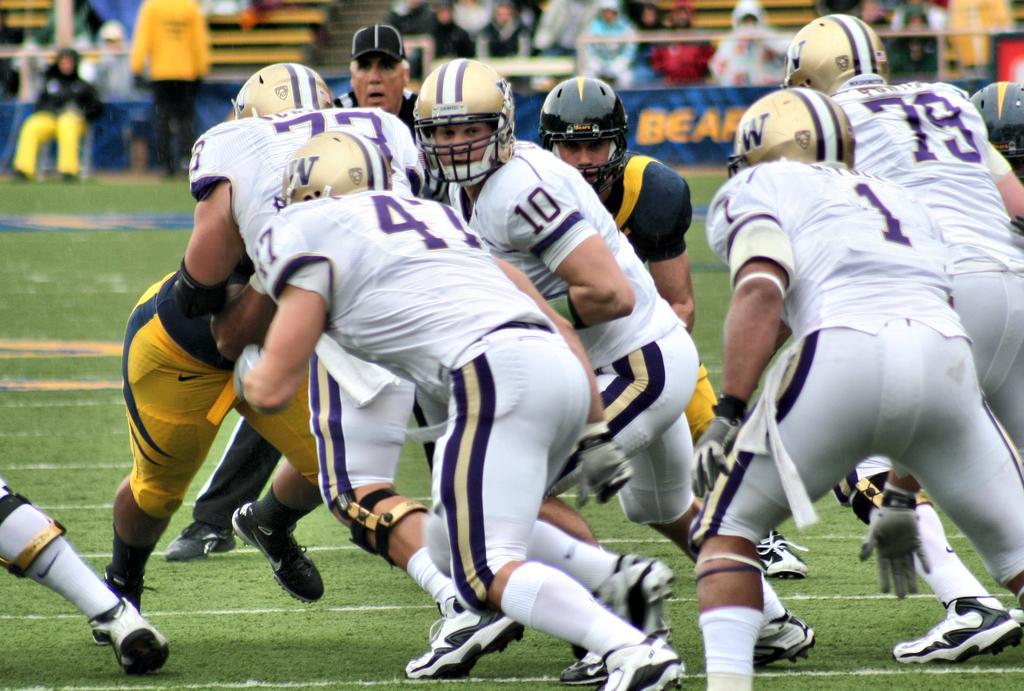Could you give a brief overview of what you see in this image? In this image it seems like it is a rugby match. There are rugby players fighting for the ball on the ground. All the rugby players are wearing the helmets. In the background there are spectators sitting in the chairs and watching the game. On the ground there is grass. 